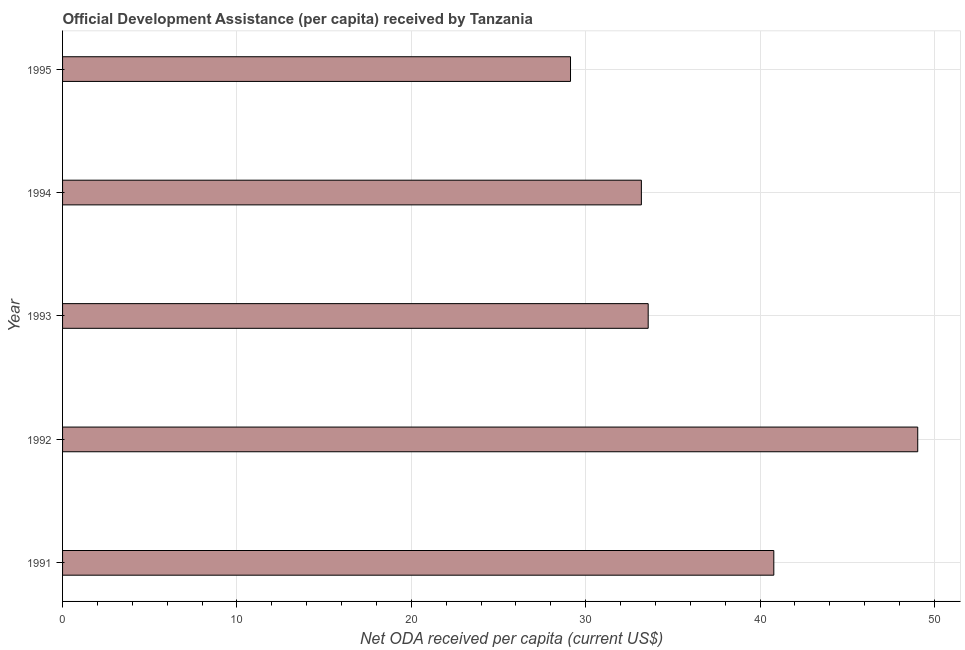Does the graph contain any zero values?
Ensure brevity in your answer.  No. Does the graph contain grids?
Keep it short and to the point. Yes. What is the title of the graph?
Offer a very short reply. Official Development Assistance (per capita) received by Tanzania. What is the label or title of the X-axis?
Give a very brief answer. Net ODA received per capita (current US$). What is the net oda received per capita in 1994?
Your answer should be compact. 33.19. Across all years, what is the maximum net oda received per capita?
Ensure brevity in your answer.  49.04. Across all years, what is the minimum net oda received per capita?
Provide a short and direct response. 29.13. In which year was the net oda received per capita maximum?
Your response must be concise. 1992. In which year was the net oda received per capita minimum?
Ensure brevity in your answer.  1995. What is the sum of the net oda received per capita?
Provide a short and direct response. 185.73. What is the difference between the net oda received per capita in 1993 and 1994?
Offer a terse response. 0.39. What is the average net oda received per capita per year?
Offer a very short reply. 37.15. What is the median net oda received per capita?
Give a very brief answer. 33.58. In how many years, is the net oda received per capita greater than 32 US$?
Offer a very short reply. 4. What is the difference between the highest and the second highest net oda received per capita?
Ensure brevity in your answer.  8.25. Is the sum of the net oda received per capita in 1991 and 1995 greater than the maximum net oda received per capita across all years?
Ensure brevity in your answer.  Yes. What is the difference between the highest and the lowest net oda received per capita?
Offer a very short reply. 19.91. What is the Net ODA received per capita (current US$) in 1991?
Ensure brevity in your answer.  40.79. What is the Net ODA received per capita (current US$) in 1992?
Make the answer very short. 49.04. What is the Net ODA received per capita (current US$) of 1993?
Give a very brief answer. 33.58. What is the Net ODA received per capita (current US$) of 1994?
Offer a terse response. 33.19. What is the Net ODA received per capita (current US$) of 1995?
Offer a terse response. 29.13. What is the difference between the Net ODA received per capita (current US$) in 1991 and 1992?
Provide a succinct answer. -8.25. What is the difference between the Net ODA received per capita (current US$) in 1991 and 1993?
Keep it short and to the point. 7.2. What is the difference between the Net ODA received per capita (current US$) in 1991 and 1994?
Make the answer very short. 7.59. What is the difference between the Net ODA received per capita (current US$) in 1991 and 1995?
Give a very brief answer. 11.66. What is the difference between the Net ODA received per capita (current US$) in 1992 and 1993?
Give a very brief answer. 15.46. What is the difference between the Net ODA received per capita (current US$) in 1992 and 1994?
Make the answer very short. 15.85. What is the difference between the Net ODA received per capita (current US$) in 1992 and 1995?
Provide a short and direct response. 19.91. What is the difference between the Net ODA received per capita (current US$) in 1993 and 1994?
Your response must be concise. 0.39. What is the difference between the Net ODA received per capita (current US$) in 1993 and 1995?
Offer a terse response. 4.45. What is the difference between the Net ODA received per capita (current US$) in 1994 and 1995?
Your answer should be very brief. 4.06. What is the ratio of the Net ODA received per capita (current US$) in 1991 to that in 1992?
Offer a very short reply. 0.83. What is the ratio of the Net ODA received per capita (current US$) in 1991 to that in 1993?
Ensure brevity in your answer.  1.22. What is the ratio of the Net ODA received per capita (current US$) in 1991 to that in 1994?
Give a very brief answer. 1.23. What is the ratio of the Net ODA received per capita (current US$) in 1991 to that in 1995?
Your response must be concise. 1.4. What is the ratio of the Net ODA received per capita (current US$) in 1992 to that in 1993?
Your answer should be compact. 1.46. What is the ratio of the Net ODA received per capita (current US$) in 1992 to that in 1994?
Provide a succinct answer. 1.48. What is the ratio of the Net ODA received per capita (current US$) in 1992 to that in 1995?
Your answer should be very brief. 1.68. What is the ratio of the Net ODA received per capita (current US$) in 1993 to that in 1995?
Offer a very short reply. 1.15. What is the ratio of the Net ODA received per capita (current US$) in 1994 to that in 1995?
Provide a succinct answer. 1.14. 